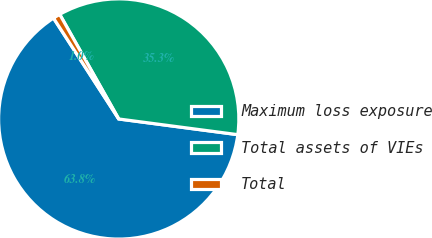<chart> <loc_0><loc_0><loc_500><loc_500><pie_chart><fcel>Maximum loss exposure<fcel>Total assets of VIEs<fcel>Total<nl><fcel>63.78%<fcel>35.26%<fcel>0.96%<nl></chart> 